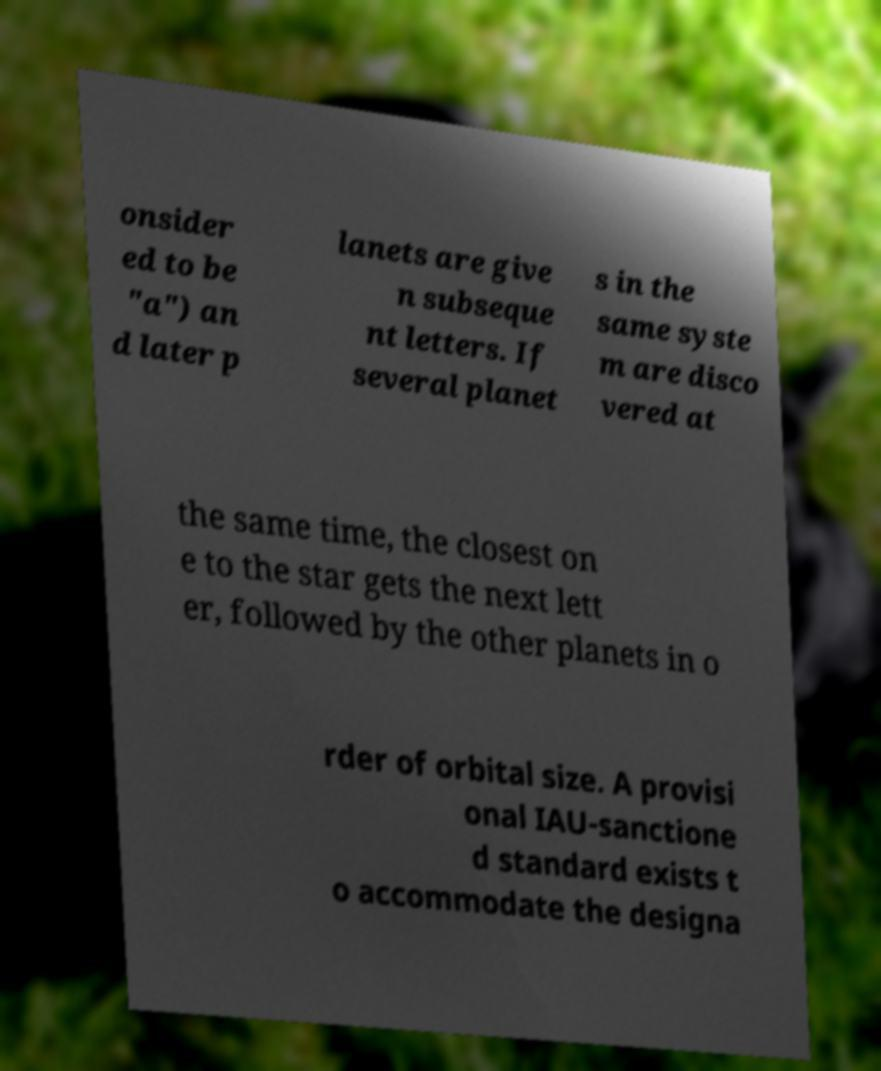For documentation purposes, I need the text within this image transcribed. Could you provide that? onsider ed to be "a") an d later p lanets are give n subseque nt letters. If several planet s in the same syste m are disco vered at the same time, the closest on e to the star gets the next lett er, followed by the other planets in o rder of orbital size. A provisi onal IAU-sanctione d standard exists t o accommodate the designa 